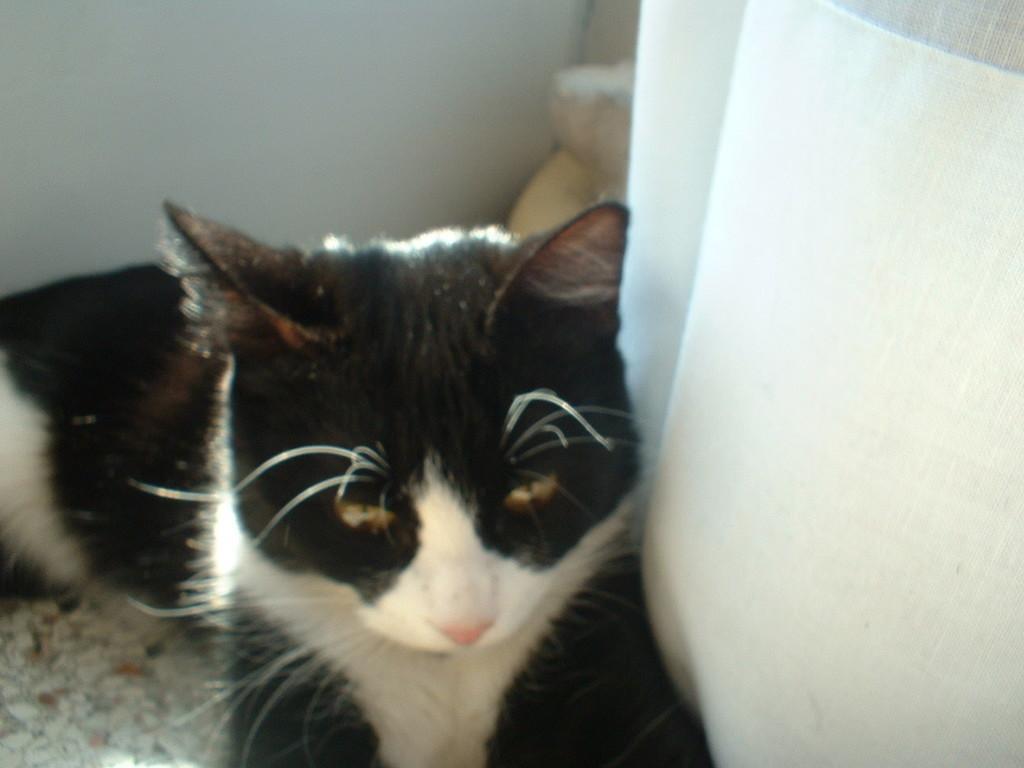Describe this image in one or two sentences. It is a cat which is in black and white color. 